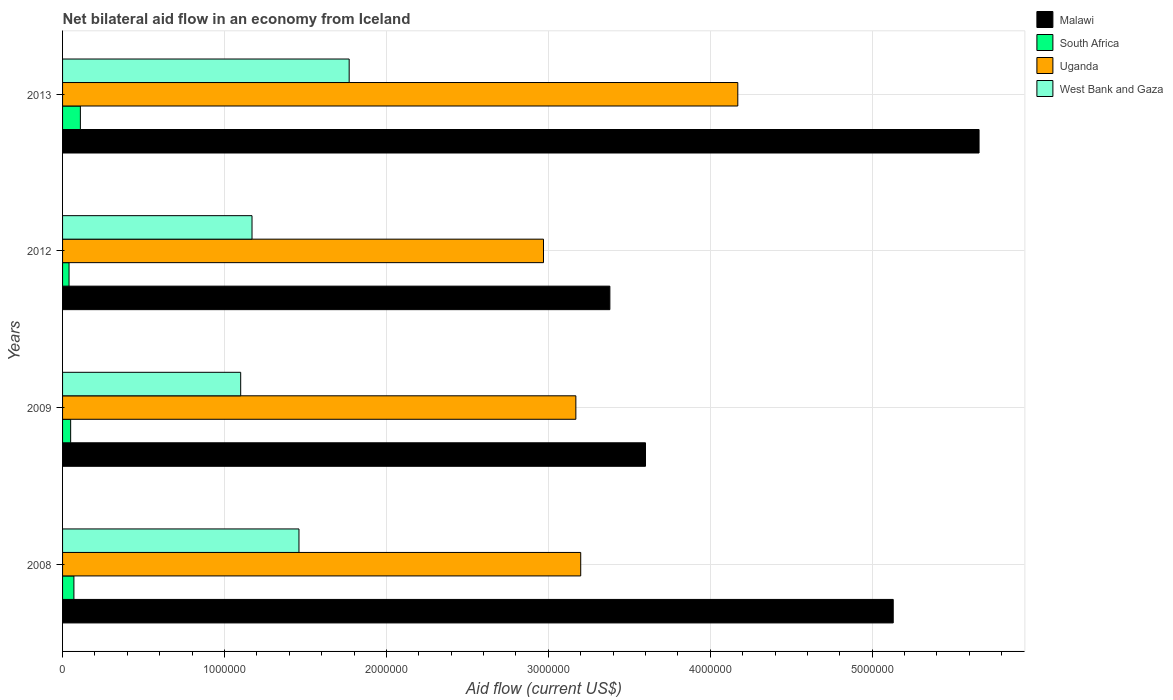How many different coloured bars are there?
Provide a succinct answer. 4. How many groups of bars are there?
Offer a terse response. 4. How many bars are there on the 3rd tick from the bottom?
Your response must be concise. 4. What is the label of the 3rd group of bars from the top?
Make the answer very short. 2009. In how many cases, is the number of bars for a given year not equal to the number of legend labels?
Keep it short and to the point. 0. What is the net bilateral aid flow in South Africa in 2013?
Ensure brevity in your answer.  1.10e+05. Across all years, what is the maximum net bilateral aid flow in South Africa?
Provide a short and direct response. 1.10e+05. Across all years, what is the minimum net bilateral aid flow in Uganda?
Your answer should be very brief. 2.97e+06. In which year was the net bilateral aid flow in West Bank and Gaza maximum?
Provide a succinct answer. 2013. What is the total net bilateral aid flow in Malawi in the graph?
Your response must be concise. 1.78e+07. What is the difference between the net bilateral aid flow in West Bank and Gaza in 2009 and the net bilateral aid flow in South Africa in 2012?
Your answer should be compact. 1.06e+06. What is the average net bilateral aid flow in West Bank and Gaza per year?
Offer a terse response. 1.38e+06. In the year 2008, what is the difference between the net bilateral aid flow in South Africa and net bilateral aid flow in Uganda?
Provide a short and direct response. -3.13e+06. In how many years, is the net bilateral aid flow in Malawi greater than 200000 US$?
Provide a succinct answer. 4. What is the ratio of the net bilateral aid flow in West Bank and Gaza in 2008 to that in 2012?
Your response must be concise. 1.25. Is the difference between the net bilateral aid flow in South Africa in 2009 and 2013 greater than the difference between the net bilateral aid flow in Uganda in 2009 and 2013?
Offer a very short reply. Yes. What is the difference between the highest and the lowest net bilateral aid flow in Malawi?
Provide a short and direct response. 2.28e+06. In how many years, is the net bilateral aid flow in West Bank and Gaza greater than the average net bilateral aid flow in West Bank and Gaza taken over all years?
Your answer should be compact. 2. Is it the case that in every year, the sum of the net bilateral aid flow in West Bank and Gaza and net bilateral aid flow in Uganda is greater than the sum of net bilateral aid flow in Malawi and net bilateral aid flow in South Africa?
Keep it short and to the point. No. What does the 1st bar from the top in 2008 represents?
Provide a short and direct response. West Bank and Gaza. What does the 3rd bar from the bottom in 2012 represents?
Offer a terse response. Uganda. Is it the case that in every year, the sum of the net bilateral aid flow in Malawi and net bilateral aid flow in South Africa is greater than the net bilateral aid flow in Uganda?
Your answer should be very brief. Yes. How many bars are there?
Provide a short and direct response. 16. What is the difference between two consecutive major ticks on the X-axis?
Offer a terse response. 1.00e+06. Are the values on the major ticks of X-axis written in scientific E-notation?
Your answer should be compact. No. How many legend labels are there?
Keep it short and to the point. 4. What is the title of the graph?
Keep it short and to the point. Net bilateral aid flow in an economy from Iceland. What is the label or title of the Y-axis?
Your answer should be compact. Years. What is the Aid flow (current US$) in Malawi in 2008?
Give a very brief answer. 5.13e+06. What is the Aid flow (current US$) in South Africa in 2008?
Offer a very short reply. 7.00e+04. What is the Aid flow (current US$) of Uganda in 2008?
Give a very brief answer. 3.20e+06. What is the Aid flow (current US$) of West Bank and Gaza in 2008?
Offer a very short reply. 1.46e+06. What is the Aid flow (current US$) in Malawi in 2009?
Ensure brevity in your answer.  3.60e+06. What is the Aid flow (current US$) in South Africa in 2009?
Your answer should be compact. 5.00e+04. What is the Aid flow (current US$) in Uganda in 2009?
Provide a succinct answer. 3.17e+06. What is the Aid flow (current US$) of West Bank and Gaza in 2009?
Your answer should be very brief. 1.10e+06. What is the Aid flow (current US$) in Malawi in 2012?
Ensure brevity in your answer.  3.38e+06. What is the Aid flow (current US$) in Uganda in 2012?
Your answer should be very brief. 2.97e+06. What is the Aid flow (current US$) of West Bank and Gaza in 2012?
Provide a short and direct response. 1.17e+06. What is the Aid flow (current US$) in Malawi in 2013?
Offer a very short reply. 5.66e+06. What is the Aid flow (current US$) in Uganda in 2013?
Offer a terse response. 4.17e+06. What is the Aid flow (current US$) in West Bank and Gaza in 2013?
Provide a succinct answer. 1.77e+06. Across all years, what is the maximum Aid flow (current US$) in Malawi?
Offer a very short reply. 5.66e+06. Across all years, what is the maximum Aid flow (current US$) in South Africa?
Offer a very short reply. 1.10e+05. Across all years, what is the maximum Aid flow (current US$) in Uganda?
Give a very brief answer. 4.17e+06. Across all years, what is the maximum Aid flow (current US$) in West Bank and Gaza?
Keep it short and to the point. 1.77e+06. Across all years, what is the minimum Aid flow (current US$) of Malawi?
Your response must be concise. 3.38e+06. Across all years, what is the minimum Aid flow (current US$) of South Africa?
Offer a terse response. 4.00e+04. Across all years, what is the minimum Aid flow (current US$) in Uganda?
Your answer should be very brief. 2.97e+06. Across all years, what is the minimum Aid flow (current US$) in West Bank and Gaza?
Your response must be concise. 1.10e+06. What is the total Aid flow (current US$) of Malawi in the graph?
Provide a short and direct response. 1.78e+07. What is the total Aid flow (current US$) in South Africa in the graph?
Your answer should be very brief. 2.70e+05. What is the total Aid flow (current US$) of Uganda in the graph?
Your response must be concise. 1.35e+07. What is the total Aid flow (current US$) in West Bank and Gaza in the graph?
Offer a terse response. 5.50e+06. What is the difference between the Aid flow (current US$) of Malawi in 2008 and that in 2009?
Your answer should be compact. 1.53e+06. What is the difference between the Aid flow (current US$) in South Africa in 2008 and that in 2009?
Provide a short and direct response. 2.00e+04. What is the difference between the Aid flow (current US$) of Uganda in 2008 and that in 2009?
Offer a terse response. 3.00e+04. What is the difference between the Aid flow (current US$) of West Bank and Gaza in 2008 and that in 2009?
Make the answer very short. 3.60e+05. What is the difference between the Aid flow (current US$) of Malawi in 2008 and that in 2012?
Your answer should be very brief. 1.75e+06. What is the difference between the Aid flow (current US$) of South Africa in 2008 and that in 2012?
Offer a terse response. 3.00e+04. What is the difference between the Aid flow (current US$) of Uganda in 2008 and that in 2012?
Offer a terse response. 2.30e+05. What is the difference between the Aid flow (current US$) of West Bank and Gaza in 2008 and that in 2012?
Keep it short and to the point. 2.90e+05. What is the difference between the Aid flow (current US$) in Malawi in 2008 and that in 2013?
Give a very brief answer. -5.30e+05. What is the difference between the Aid flow (current US$) of South Africa in 2008 and that in 2013?
Give a very brief answer. -4.00e+04. What is the difference between the Aid flow (current US$) of Uganda in 2008 and that in 2013?
Your answer should be compact. -9.70e+05. What is the difference between the Aid flow (current US$) of West Bank and Gaza in 2008 and that in 2013?
Provide a short and direct response. -3.10e+05. What is the difference between the Aid flow (current US$) in South Africa in 2009 and that in 2012?
Your answer should be very brief. 10000. What is the difference between the Aid flow (current US$) of Uganda in 2009 and that in 2012?
Offer a very short reply. 2.00e+05. What is the difference between the Aid flow (current US$) in Malawi in 2009 and that in 2013?
Ensure brevity in your answer.  -2.06e+06. What is the difference between the Aid flow (current US$) of South Africa in 2009 and that in 2013?
Make the answer very short. -6.00e+04. What is the difference between the Aid flow (current US$) in West Bank and Gaza in 2009 and that in 2013?
Offer a terse response. -6.70e+05. What is the difference between the Aid flow (current US$) of Malawi in 2012 and that in 2013?
Make the answer very short. -2.28e+06. What is the difference between the Aid flow (current US$) in South Africa in 2012 and that in 2013?
Give a very brief answer. -7.00e+04. What is the difference between the Aid flow (current US$) in Uganda in 2012 and that in 2013?
Offer a terse response. -1.20e+06. What is the difference between the Aid flow (current US$) in West Bank and Gaza in 2012 and that in 2013?
Offer a terse response. -6.00e+05. What is the difference between the Aid flow (current US$) of Malawi in 2008 and the Aid flow (current US$) of South Africa in 2009?
Your answer should be compact. 5.08e+06. What is the difference between the Aid flow (current US$) in Malawi in 2008 and the Aid flow (current US$) in Uganda in 2009?
Your response must be concise. 1.96e+06. What is the difference between the Aid flow (current US$) of Malawi in 2008 and the Aid flow (current US$) of West Bank and Gaza in 2009?
Keep it short and to the point. 4.03e+06. What is the difference between the Aid flow (current US$) in South Africa in 2008 and the Aid flow (current US$) in Uganda in 2009?
Offer a very short reply. -3.10e+06. What is the difference between the Aid flow (current US$) of South Africa in 2008 and the Aid flow (current US$) of West Bank and Gaza in 2009?
Ensure brevity in your answer.  -1.03e+06. What is the difference between the Aid flow (current US$) of Uganda in 2008 and the Aid flow (current US$) of West Bank and Gaza in 2009?
Keep it short and to the point. 2.10e+06. What is the difference between the Aid flow (current US$) of Malawi in 2008 and the Aid flow (current US$) of South Africa in 2012?
Your answer should be compact. 5.09e+06. What is the difference between the Aid flow (current US$) of Malawi in 2008 and the Aid flow (current US$) of Uganda in 2012?
Your answer should be very brief. 2.16e+06. What is the difference between the Aid flow (current US$) in Malawi in 2008 and the Aid flow (current US$) in West Bank and Gaza in 2012?
Offer a very short reply. 3.96e+06. What is the difference between the Aid flow (current US$) in South Africa in 2008 and the Aid flow (current US$) in Uganda in 2012?
Offer a terse response. -2.90e+06. What is the difference between the Aid flow (current US$) in South Africa in 2008 and the Aid flow (current US$) in West Bank and Gaza in 2012?
Your answer should be compact. -1.10e+06. What is the difference between the Aid flow (current US$) in Uganda in 2008 and the Aid flow (current US$) in West Bank and Gaza in 2012?
Your response must be concise. 2.03e+06. What is the difference between the Aid flow (current US$) of Malawi in 2008 and the Aid flow (current US$) of South Africa in 2013?
Make the answer very short. 5.02e+06. What is the difference between the Aid flow (current US$) of Malawi in 2008 and the Aid flow (current US$) of Uganda in 2013?
Provide a succinct answer. 9.60e+05. What is the difference between the Aid flow (current US$) of Malawi in 2008 and the Aid flow (current US$) of West Bank and Gaza in 2013?
Your response must be concise. 3.36e+06. What is the difference between the Aid flow (current US$) of South Africa in 2008 and the Aid flow (current US$) of Uganda in 2013?
Your answer should be compact. -4.10e+06. What is the difference between the Aid flow (current US$) in South Africa in 2008 and the Aid flow (current US$) in West Bank and Gaza in 2013?
Ensure brevity in your answer.  -1.70e+06. What is the difference between the Aid flow (current US$) of Uganda in 2008 and the Aid flow (current US$) of West Bank and Gaza in 2013?
Keep it short and to the point. 1.43e+06. What is the difference between the Aid flow (current US$) in Malawi in 2009 and the Aid flow (current US$) in South Africa in 2012?
Provide a succinct answer. 3.56e+06. What is the difference between the Aid flow (current US$) of Malawi in 2009 and the Aid flow (current US$) of Uganda in 2012?
Your response must be concise. 6.30e+05. What is the difference between the Aid flow (current US$) in Malawi in 2009 and the Aid flow (current US$) in West Bank and Gaza in 2012?
Provide a succinct answer. 2.43e+06. What is the difference between the Aid flow (current US$) in South Africa in 2009 and the Aid flow (current US$) in Uganda in 2012?
Provide a short and direct response. -2.92e+06. What is the difference between the Aid flow (current US$) in South Africa in 2009 and the Aid flow (current US$) in West Bank and Gaza in 2012?
Keep it short and to the point. -1.12e+06. What is the difference between the Aid flow (current US$) in Malawi in 2009 and the Aid flow (current US$) in South Africa in 2013?
Give a very brief answer. 3.49e+06. What is the difference between the Aid flow (current US$) in Malawi in 2009 and the Aid flow (current US$) in Uganda in 2013?
Your response must be concise. -5.70e+05. What is the difference between the Aid flow (current US$) in Malawi in 2009 and the Aid flow (current US$) in West Bank and Gaza in 2013?
Offer a terse response. 1.83e+06. What is the difference between the Aid flow (current US$) of South Africa in 2009 and the Aid flow (current US$) of Uganda in 2013?
Make the answer very short. -4.12e+06. What is the difference between the Aid flow (current US$) in South Africa in 2009 and the Aid flow (current US$) in West Bank and Gaza in 2013?
Your answer should be compact. -1.72e+06. What is the difference between the Aid flow (current US$) of Uganda in 2009 and the Aid flow (current US$) of West Bank and Gaza in 2013?
Ensure brevity in your answer.  1.40e+06. What is the difference between the Aid flow (current US$) of Malawi in 2012 and the Aid flow (current US$) of South Africa in 2013?
Your answer should be very brief. 3.27e+06. What is the difference between the Aid flow (current US$) of Malawi in 2012 and the Aid flow (current US$) of Uganda in 2013?
Make the answer very short. -7.90e+05. What is the difference between the Aid flow (current US$) in Malawi in 2012 and the Aid flow (current US$) in West Bank and Gaza in 2013?
Offer a terse response. 1.61e+06. What is the difference between the Aid flow (current US$) of South Africa in 2012 and the Aid flow (current US$) of Uganda in 2013?
Offer a terse response. -4.13e+06. What is the difference between the Aid flow (current US$) in South Africa in 2012 and the Aid flow (current US$) in West Bank and Gaza in 2013?
Your answer should be compact. -1.73e+06. What is the difference between the Aid flow (current US$) of Uganda in 2012 and the Aid flow (current US$) of West Bank and Gaza in 2013?
Your answer should be very brief. 1.20e+06. What is the average Aid flow (current US$) in Malawi per year?
Give a very brief answer. 4.44e+06. What is the average Aid flow (current US$) of South Africa per year?
Make the answer very short. 6.75e+04. What is the average Aid flow (current US$) of Uganda per year?
Make the answer very short. 3.38e+06. What is the average Aid flow (current US$) of West Bank and Gaza per year?
Offer a terse response. 1.38e+06. In the year 2008, what is the difference between the Aid flow (current US$) in Malawi and Aid flow (current US$) in South Africa?
Give a very brief answer. 5.06e+06. In the year 2008, what is the difference between the Aid flow (current US$) of Malawi and Aid flow (current US$) of Uganda?
Give a very brief answer. 1.93e+06. In the year 2008, what is the difference between the Aid flow (current US$) in Malawi and Aid flow (current US$) in West Bank and Gaza?
Provide a short and direct response. 3.67e+06. In the year 2008, what is the difference between the Aid flow (current US$) of South Africa and Aid flow (current US$) of Uganda?
Ensure brevity in your answer.  -3.13e+06. In the year 2008, what is the difference between the Aid flow (current US$) in South Africa and Aid flow (current US$) in West Bank and Gaza?
Ensure brevity in your answer.  -1.39e+06. In the year 2008, what is the difference between the Aid flow (current US$) of Uganda and Aid flow (current US$) of West Bank and Gaza?
Your answer should be compact. 1.74e+06. In the year 2009, what is the difference between the Aid flow (current US$) of Malawi and Aid flow (current US$) of South Africa?
Offer a terse response. 3.55e+06. In the year 2009, what is the difference between the Aid flow (current US$) in Malawi and Aid flow (current US$) in West Bank and Gaza?
Your response must be concise. 2.50e+06. In the year 2009, what is the difference between the Aid flow (current US$) in South Africa and Aid flow (current US$) in Uganda?
Give a very brief answer. -3.12e+06. In the year 2009, what is the difference between the Aid flow (current US$) in South Africa and Aid flow (current US$) in West Bank and Gaza?
Provide a short and direct response. -1.05e+06. In the year 2009, what is the difference between the Aid flow (current US$) of Uganda and Aid flow (current US$) of West Bank and Gaza?
Provide a succinct answer. 2.07e+06. In the year 2012, what is the difference between the Aid flow (current US$) of Malawi and Aid flow (current US$) of South Africa?
Your answer should be very brief. 3.34e+06. In the year 2012, what is the difference between the Aid flow (current US$) of Malawi and Aid flow (current US$) of West Bank and Gaza?
Make the answer very short. 2.21e+06. In the year 2012, what is the difference between the Aid flow (current US$) in South Africa and Aid flow (current US$) in Uganda?
Keep it short and to the point. -2.93e+06. In the year 2012, what is the difference between the Aid flow (current US$) in South Africa and Aid flow (current US$) in West Bank and Gaza?
Your response must be concise. -1.13e+06. In the year 2012, what is the difference between the Aid flow (current US$) in Uganda and Aid flow (current US$) in West Bank and Gaza?
Give a very brief answer. 1.80e+06. In the year 2013, what is the difference between the Aid flow (current US$) in Malawi and Aid flow (current US$) in South Africa?
Your answer should be very brief. 5.55e+06. In the year 2013, what is the difference between the Aid flow (current US$) in Malawi and Aid flow (current US$) in Uganda?
Offer a very short reply. 1.49e+06. In the year 2013, what is the difference between the Aid flow (current US$) of Malawi and Aid flow (current US$) of West Bank and Gaza?
Keep it short and to the point. 3.89e+06. In the year 2013, what is the difference between the Aid flow (current US$) of South Africa and Aid flow (current US$) of Uganda?
Make the answer very short. -4.06e+06. In the year 2013, what is the difference between the Aid flow (current US$) of South Africa and Aid flow (current US$) of West Bank and Gaza?
Provide a succinct answer. -1.66e+06. In the year 2013, what is the difference between the Aid flow (current US$) in Uganda and Aid flow (current US$) in West Bank and Gaza?
Your answer should be very brief. 2.40e+06. What is the ratio of the Aid flow (current US$) of Malawi in 2008 to that in 2009?
Provide a short and direct response. 1.43. What is the ratio of the Aid flow (current US$) in South Africa in 2008 to that in 2009?
Give a very brief answer. 1.4. What is the ratio of the Aid flow (current US$) in Uganda in 2008 to that in 2009?
Keep it short and to the point. 1.01. What is the ratio of the Aid flow (current US$) in West Bank and Gaza in 2008 to that in 2009?
Give a very brief answer. 1.33. What is the ratio of the Aid flow (current US$) in Malawi in 2008 to that in 2012?
Give a very brief answer. 1.52. What is the ratio of the Aid flow (current US$) in South Africa in 2008 to that in 2012?
Ensure brevity in your answer.  1.75. What is the ratio of the Aid flow (current US$) of Uganda in 2008 to that in 2012?
Offer a terse response. 1.08. What is the ratio of the Aid flow (current US$) of West Bank and Gaza in 2008 to that in 2012?
Your answer should be compact. 1.25. What is the ratio of the Aid flow (current US$) of Malawi in 2008 to that in 2013?
Your response must be concise. 0.91. What is the ratio of the Aid flow (current US$) in South Africa in 2008 to that in 2013?
Your answer should be compact. 0.64. What is the ratio of the Aid flow (current US$) in Uganda in 2008 to that in 2013?
Keep it short and to the point. 0.77. What is the ratio of the Aid flow (current US$) in West Bank and Gaza in 2008 to that in 2013?
Your answer should be very brief. 0.82. What is the ratio of the Aid flow (current US$) in Malawi in 2009 to that in 2012?
Provide a short and direct response. 1.07. What is the ratio of the Aid flow (current US$) of Uganda in 2009 to that in 2012?
Provide a succinct answer. 1.07. What is the ratio of the Aid flow (current US$) in West Bank and Gaza in 2009 to that in 2012?
Keep it short and to the point. 0.94. What is the ratio of the Aid flow (current US$) of Malawi in 2009 to that in 2013?
Your answer should be compact. 0.64. What is the ratio of the Aid flow (current US$) of South Africa in 2009 to that in 2013?
Keep it short and to the point. 0.45. What is the ratio of the Aid flow (current US$) of Uganda in 2009 to that in 2013?
Ensure brevity in your answer.  0.76. What is the ratio of the Aid flow (current US$) in West Bank and Gaza in 2009 to that in 2013?
Your response must be concise. 0.62. What is the ratio of the Aid flow (current US$) of Malawi in 2012 to that in 2013?
Provide a short and direct response. 0.6. What is the ratio of the Aid flow (current US$) of South Africa in 2012 to that in 2013?
Provide a succinct answer. 0.36. What is the ratio of the Aid flow (current US$) in Uganda in 2012 to that in 2013?
Offer a very short reply. 0.71. What is the ratio of the Aid flow (current US$) in West Bank and Gaza in 2012 to that in 2013?
Keep it short and to the point. 0.66. What is the difference between the highest and the second highest Aid flow (current US$) in Malawi?
Your answer should be very brief. 5.30e+05. What is the difference between the highest and the second highest Aid flow (current US$) of Uganda?
Offer a terse response. 9.70e+05. What is the difference between the highest and the lowest Aid flow (current US$) in Malawi?
Make the answer very short. 2.28e+06. What is the difference between the highest and the lowest Aid flow (current US$) in Uganda?
Ensure brevity in your answer.  1.20e+06. What is the difference between the highest and the lowest Aid flow (current US$) of West Bank and Gaza?
Provide a short and direct response. 6.70e+05. 